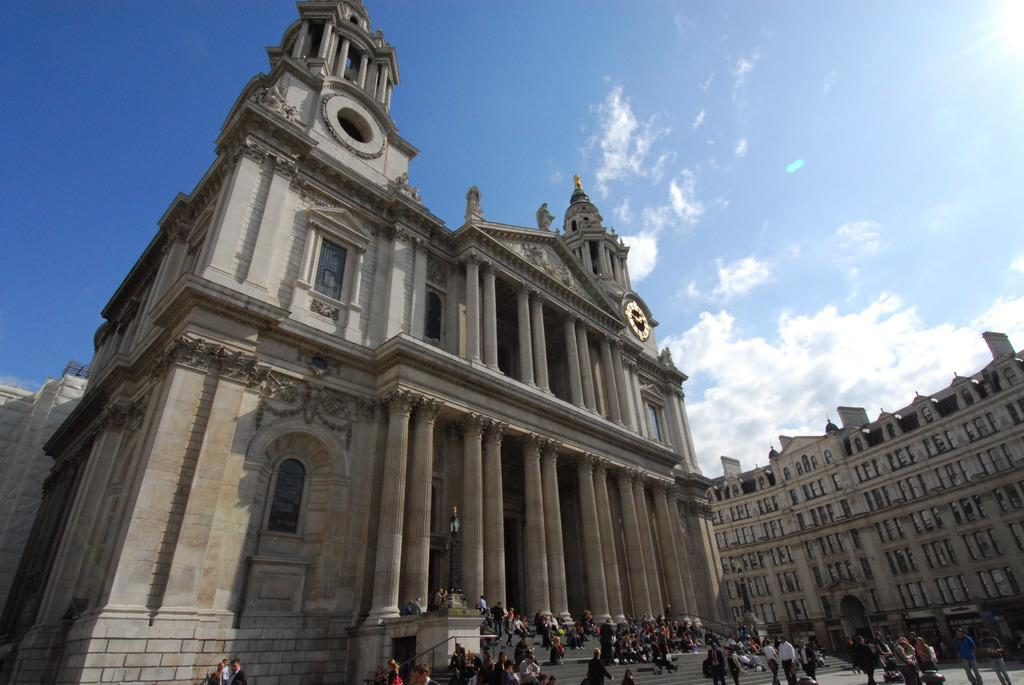What is the main subject of the image? The main subject of the image is a group of people standing. What else can be seen in the image besides the people? There is a light pole and buildings visible in the image. What is visible in the background of the image? The sky is visible in the image. What type of pie is being served to the people in the image? There is no pie present in the image; it features a group of people standing with a light pole and buildings in the background. 